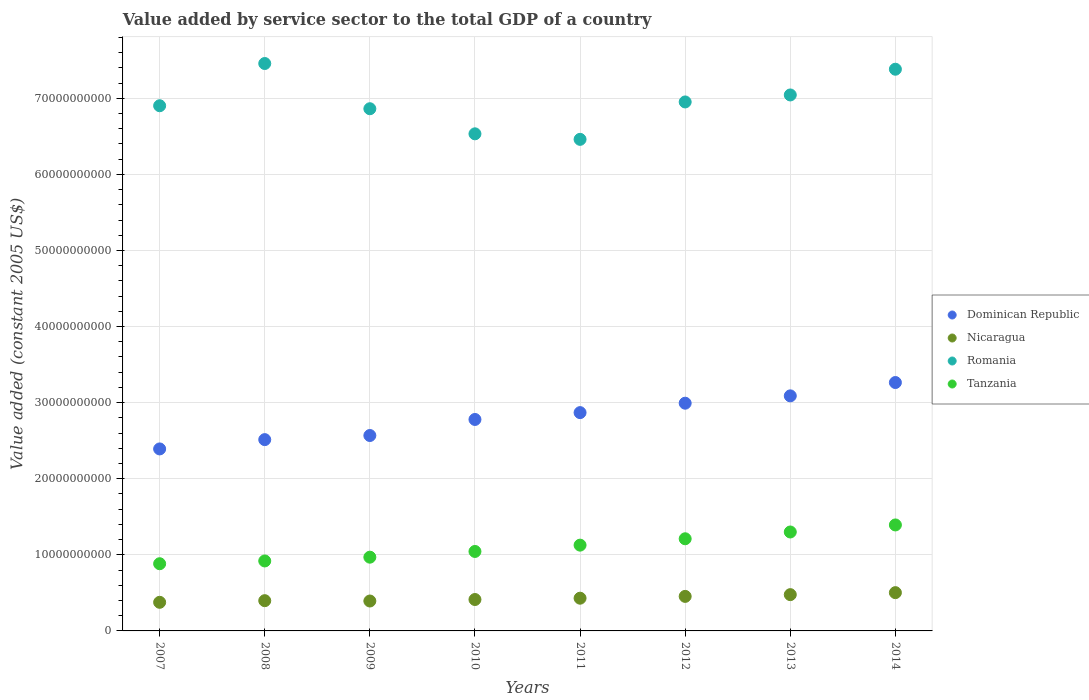What is the value added by service sector in Tanzania in 2011?
Ensure brevity in your answer.  1.13e+1. Across all years, what is the maximum value added by service sector in Nicaragua?
Offer a very short reply. 5.03e+09. Across all years, what is the minimum value added by service sector in Tanzania?
Provide a short and direct response. 8.83e+09. In which year was the value added by service sector in Dominican Republic maximum?
Ensure brevity in your answer.  2014. What is the total value added by service sector in Dominican Republic in the graph?
Ensure brevity in your answer.  2.25e+11. What is the difference between the value added by service sector in Dominican Republic in 2007 and that in 2010?
Provide a succinct answer. -3.87e+09. What is the difference between the value added by service sector in Dominican Republic in 2007 and the value added by service sector in Romania in 2012?
Keep it short and to the point. -4.56e+1. What is the average value added by service sector in Dominican Republic per year?
Provide a succinct answer. 2.81e+1. In the year 2012, what is the difference between the value added by service sector in Dominican Republic and value added by service sector in Nicaragua?
Ensure brevity in your answer.  2.54e+1. What is the ratio of the value added by service sector in Dominican Republic in 2007 to that in 2013?
Ensure brevity in your answer.  0.77. Is the value added by service sector in Romania in 2011 less than that in 2013?
Make the answer very short. Yes. What is the difference between the highest and the second highest value added by service sector in Tanzania?
Ensure brevity in your answer.  9.26e+08. What is the difference between the highest and the lowest value added by service sector in Romania?
Give a very brief answer. 9.97e+09. In how many years, is the value added by service sector in Nicaragua greater than the average value added by service sector in Nicaragua taken over all years?
Your answer should be very brief. 3. Is it the case that in every year, the sum of the value added by service sector in Tanzania and value added by service sector in Dominican Republic  is greater than the value added by service sector in Romania?
Give a very brief answer. No. Does the value added by service sector in Nicaragua monotonically increase over the years?
Make the answer very short. No. Is the value added by service sector in Nicaragua strictly less than the value added by service sector in Romania over the years?
Ensure brevity in your answer.  Yes. How many years are there in the graph?
Provide a succinct answer. 8. Are the values on the major ticks of Y-axis written in scientific E-notation?
Your answer should be compact. No. Does the graph contain any zero values?
Make the answer very short. No. Does the graph contain grids?
Keep it short and to the point. Yes. How many legend labels are there?
Make the answer very short. 4. How are the legend labels stacked?
Ensure brevity in your answer.  Vertical. What is the title of the graph?
Give a very brief answer. Value added by service sector to the total GDP of a country. Does "Costa Rica" appear as one of the legend labels in the graph?
Ensure brevity in your answer.  No. What is the label or title of the X-axis?
Offer a very short reply. Years. What is the label or title of the Y-axis?
Ensure brevity in your answer.  Value added (constant 2005 US$). What is the Value added (constant 2005 US$) of Dominican Republic in 2007?
Your response must be concise. 2.39e+1. What is the Value added (constant 2005 US$) in Nicaragua in 2007?
Your response must be concise. 3.76e+09. What is the Value added (constant 2005 US$) of Romania in 2007?
Provide a short and direct response. 6.90e+1. What is the Value added (constant 2005 US$) in Tanzania in 2007?
Your answer should be very brief. 8.83e+09. What is the Value added (constant 2005 US$) in Dominican Republic in 2008?
Keep it short and to the point. 2.51e+1. What is the Value added (constant 2005 US$) in Nicaragua in 2008?
Give a very brief answer. 3.97e+09. What is the Value added (constant 2005 US$) in Romania in 2008?
Your answer should be compact. 7.46e+1. What is the Value added (constant 2005 US$) of Tanzania in 2008?
Give a very brief answer. 9.20e+09. What is the Value added (constant 2005 US$) in Dominican Republic in 2009?
Offer a very short reply. 2.57e+1. What is the Value added (constant 2005 US$) of Nicaragua in 2009?
Give a very brief answer. 3.93e+09. What is the Value added (constant 2005 US$) of Romania in 2009?
Keep it short and to the point. 6.86e+1. What is the Value added (constant 2005 US$) in Tanzania in 2009?
Offer a very short reply. 9.69e+09. What is the Value added (constant 2005 US$) in Dominican Republic in 2010?
Give a very brief answer. 2.78e+1. What is the Value added (constant 2005 US$) in Nicaragua in 2010?
Your answer should be very brief. 4.13e+09. What is the Value added (constant 2005 US$) in Romania in 2010?
Your answer should be very brief. 6.53e+1. What is the Value added (constant 2005 US$) of Tanzania in 2010?
Ensure brevity in your answer.  1.04e+1. What is the Value added (constant 2005 US$) of Dominican Republic in 2011?
Make the answer very short. 2.87e+1. What is the Value added (constant 2005 US$) of Nicaragua in 2011?
Your answer should be very brief. 4.30e+09. What is the Value added (constant 2005 US$) in Romania in 2011?
Offer a very short reply. 6.46e+1. What is the Value added (constant 2005 US$) in Tanzania in 2011?
Offer a very short reply. 1.13e+1. What is the Value added (constant 2005 US$) of Dominican Republic in 2012?
Your answer should be compact. 2.99e+1. What is the Value added (constant 2005 US$) of Nicaragua in 2012?
Your answer should be compact. 4.54e+09. What is the Value added (constant 2005 US$) of Romania in 2012?
Provide a succinct answer. 6.95e+1. What is the Value added (constant 2005 US$) of Tanzania in 2012?
Make the answer very short. 1.21e+1. What is the Value added (constant 2005 US$) of Dominican Republic in 2013?
Make the answer very short. 3.09e+1. What is the Value added (constant 2005 US$) of Nicaragua in 2013?
Give a very brief answer. 4.77e+09. What is the Value added (constant 2005 US$) of Romania in 2013?
Your answer should be compact. 7.04e+1. What is the Value added (constant 2005 US$) in Tanzania in 2013?
Provide a succinct answer. 1.30e+1. What is the Value added (constant 2005 US$) in Dominican Republic in 2014?
Offer a terse response. 3.26e+1. What is the Value added (constant 2005 US$) in Nicaragua in 2014?
Keep it short and to the point. 5.03e+09. What is the Value added (constant 2005 US$) in Romania in 2014?
Provide a succinct answer. 7.38e+1. What is the Value added (constant 2005 US$) of Tanzania in 2014?
Keep it short and to the point. 1.39e+1. Across all years, what is the maximum Value added (constant 2005 US$) in Dominican Republic?
Provide a short and direct response. 3.26e+1. Across all years, what is the maximum Value added (constant 2005 US$) of Nicaragua?
Give a very brief answer. 5.03e+09. Across all years, what is the maximum Value added (constant 2005 US$) in Romania?
Offer a very short reply. 7.46e+1. Across all years, what is the maximum Value added (constant 2005 US$) of Tanzania?
Your answer should be compact. 1.39e+1. Across all years, what is the minimum Value added (constant 2005 US$) in Dominican Republic?
Give a very brief answer. 2.39e+1. Across all years, what is the minimum Value added (constant 2005 US$) in Nicaragua?
Give a very brief answer. 3.76e+09. Across all years, what is the minimum Value added (constant 2005 US$) of Romania?
Your response must be concise. 6.46e+1. Across all years, what is the minimum Value added (constant 2005 US$) in Tanzania?
Your response must be concise. 8.83e+09. What is the total Value added (constant 2005 US$) in Dominican Republic in the graph?
Keep it short and to the point. 2.25e+11. What is the total Value added (constant 2005 US$) of Nicaragua in the graph?
Keep it short and to the point. 3.44e+1. What is the total Value added (constant 2005 US$) of Romania in the graph?
Your answer should be very brief. 5.56e+11. What is the total Value added (constant 2005 US$) in Tanzania in the graph?
Your response must be concise. 8.85e+1. What is the difference between the Value added (constant 2005 US$) of Dominican Republic in 2007 and that in 2008?
Your answer should be very brief. -1.22e+09. What is the difference between the Value added (constant 2005 US$) in Nicaragua in 2007 and that in 2008?
Offer a very short reply. -2.14e+08. What is the difference between the Value added (constant 2005 US$) in Romania in 2007 and that in 2008?
Keep it short and to the point. -5.55e+09. What is the difference between the Value added (constant 2005 US$) in Tanzania in 2007 and that in 2008?
Your answer should be very brief. -3.64e+08. What is the difference between the Value added (constant 2005 US$) in Dominican Republic in 2007 and that in 2009?
Provide a succinct answer. -1.76e+09. What is the difference between the Value added (constant 2005 US$) of Nicaragua in 2007 and that in 2009?
Provide a short and direct response. -1.70e+08. What is the difference between the Value added (constant 2005 US$) in Romania in 2007 and that in 2009?
Provide a succinct answer. 3.93e+08. What is the difference between the Value added (constant 2005 US$) in Tanzania in 2007 and that in 2009?
Provide a short and direct response. -8.60e+08. What is the difference between the Value added (constant 2005 US$) in Dominican Republic in 2007 and that in 2010?
Provide a short and direct response. -3.87e+09. What is the difference between the Value added (constant 2005 US$) of Nicaragua in 2007 and that in 2010?
Your answer should be compact. -3.67e+08. What is the difference between the Value added (constant 2005 US$) in Romania in 2007 and that in 2010?
Provide a succinct answer. 3.69e+09. What is the difference between the Value added (constant 2005 US$) of Tanzania in 2007 and that in 2010?
Give a very brief answer. -1.61e+09. What is the difference between the Value added (constant 2005 US$) of Dominican Republic in 2007 and that in 2011?
Make the answer very short. -4.77e+09. What is the difference between the Value added (constant 2005 US$) of Nicaragua in 2007 and that in 2011?
Your answer should be compact. -5.40e+08. What is the difference between the Value added (constant 2005 US$) of Romania in 2007 and that in 2011?
Ensure brevity in your answer.  4.42e+09. What is the difference between the Value added (constant 2005 US$) in Tanzania in 2007 and that in 2011?
Keep it short and to the point. -2.44e+09. What is the difference between the Value added (constant 2005 US$) in Dominican Republic in 2007 and that in 2012?
Give a very brief answer. -6.01e+09. What is the difference between the Value added (constant 2005 US$) in Nicaragua in 2007 and that in 2012?
Your answer should be very brief. -7.78e+08. What is the difference between the Value added (constant 2005 US$) in Romania in 2007 and that in 2012?
Offer a very short reply. -4.99e+08. What is the difference between the Value added (constant 2005 US$) in Tanzania in 2007 and that in 2012?
Offer a very short reply. -3.28e+09. What is the difference between the Value added (constant 2005 US$) in Dominican Republic in 2007 and that in 2013?
Make the answer very short. -6.97e+09. What is the difference between the Value added (constant 2005 US$) of Nicaragua in 2007 and that in 2013?
Your answer should be compact. -1.01e+09. What is the difference between the Value added (constant 2005 US$) of Romania in 2007 and that in 2013?
Your answer should be very brief. -1.42e+09. What is the difference between the Value added (constant 2005 US$) in Tanzania in 2007 and that in 2013?
Your answer should be very brief. -4.17e+09. What is the difference between the Value added (constant 2005 US$) of Dominican Republic in 2007 and that in 2014?
Your response must be concise. -8.73e+09. What is the difference between the Value added (constant 2005 US$) of Nicaragua in 2007 and that in 2014?
Keep it short and to the point. -1.27e+09. What is the difference between the Value added (constant 2005 US$) in Romania in 2007 and that in 2014?
Your answer should be compact. -4.80e+09. What is the difference between the Value added (constant 2005 US$) of Tanzania in 2007 and that in 2014?
Keep it short and to the point. -5.10e+09. What is the difference between the Value added (constant 2005 US$) in Dominican Republic in 2008 and that in 2009?
Keep it short and to the point. -5.41e+08. What is the difference between the Value added (constant 2005 US$) in Nicaragua in 2008 and that in 2009?
Your answer should be very brief. 4.43e+07. What is the difference between the Value added (constant 2005 US$) of Romania in 2008 and that in 2009?
Provide a short and direct response. 5.94e+09. What is the difference between the Value added (constant 2005 US$) of Tanzania in 2008 and that in 2009?
Provide a succinct answer. -4.96e+08. What is the difference between the Value added (constant 2005 US$) of Dominican Republic in 2008 and that in 2010?
Make the answer very short. -2.65e+09. What is the difference between the Value added (constant 2005 US$) in Nicaragua in 2008 and that in 2010?
Offer a terse response. -1.53e+08. What is the difference between the Value added (constant 2005 US$) in Romania in 2008 and that in 2010?
Ensure brevity in your answer.  9.24e+09. What is the difference between the Value added (constant 2005 US$) of Tanzania in 2008 and that in 2010?
Keep it short and to the point. -1.25e+09. What is the difference between the Value added (constant 2005 US$) in Dominican Republic in 2008 and that in 2011?
Offer a terse response. -3.55e+09. What is the difference between the Value added (constant 2005 US$) in Nicaragua in 2008 and that in 2011?
Keep it short and to the point. -3.26e+08. What is the difference between the Value added (constant 2005 US$) of Romania in 2008 and that in 2011?
Keep it short and to the point. 9.97e+09. What is the difference between the Value added (constant 2005 US$) in Tanzania in 2008 and that in 2011?
Provide a short and direct response. -2.08e+09. What is the difference between the Value added (constant 2005 US$) of Dominican Republic in 2008 and that in 2012?
Your answer should be compact. -4.79e+09. What is the difference between the Value added (constant 2005 US$) of Nicaragua in 2008 and that in 2012?
Provide a short and direct response. -5.63e+08. What is the difference between the Value added (constant 2005 US$) of Romania in 2008 and that in 2012?
Your answer should be compact. 5.05e+09. What is the difference between the Value added (constant 2005 US$) in Tanzania in 2008 and that in 2012?
Give a very brief answer. -2.92e+09. What is the difference between the Value added (constant 2005 US$) of Dominican Republic in 2008 and that in 2013?
Ensure brevity in your answer.  -5.75e+09. What is the difference between the Value added (constant 2005 US$) in Nicaragua in 2008 and that in 2013?
Offer a very short reply. -7.93e+08. What is the difference between the Value added (constant 2005 US$) of Romania in 2008 and that in 2013?
Keep it short and to the point. 4.13e+09. What is the difference between the Value added (constant 2005 US$) of Tanzania in 2008 and that in 2013?
Provide a short and direct response. -3.81e+09. What is the difference between the Value added (constant 2005 US$) of Dominican Republic in 2008 and that in 2014?
Keep it short and to the point. -7.50e+09. What is the difference between the Value added (constant 2005 US$) in Nicaragua in 2008 and that in 2014?
Keep it short and to the point. -1.06e+09. What is the difference between the Value added (constant 2005 US$) of Romania in 2008 and that in 2014?
Make the answer very short. 7.50e+08. What is the difference between the Value added (constant 2005 US$) of Tanzania in 2008 and that in 2014?
Provide a short and direct response. -4.73e+09. What is the difference between the Value added (constant 2005 US$) of Dominican Republic in 2009 and that in 2010?
Keep it short and to the point. -2.11e+09. What is the difference between the Value added (constant 2005 US$) of Nicaragua in 2009 and that in 2010?
Your response must be concise. -1.97e+08. What is the difference between the Value added (constant 2005 US$) in Romania in 2009 and that in 2010?
Your answer should be very brief. 3.30e+09. What is the difference between the Value added (constant 2005 US$) in Tanzania in 2009 and that in 2010?
Make the answer very short. -7.53e+08. What is the difference between the Value added (constant 2005 US$) in Dominican Republic in 2009 and that in 2011?
Your answer should be very brief. -3.01e+09. What is the difference between the Value added (constant 2005 US$) of Nicaragua in 2009 and that in 2011?
Keep it short and to the point. -3.70e+08. What is the difference between the Value added (constant 2005 US$) of Romania in 2009 and that in 2011?
Your response must be concise. 4.02e+09. What is the difference between the Value added (constant 2005 US$) of Tanzania in 2009 and that in 2011?
Give a very brief answer. -1.58e+09. What is the difference between the Value added (constant 2005 US$) in Dominican Republic in 2009 and that in 2012?
Your response must be concise. -4.25e+09. What is the difference between the Value added (constant 2005 US$) in Nicaragua in 2009 and that in 2012?
Your response must be concise. -6.08e+08. What is the difference between the Value added (constant 2005 US$) of Romania in 2009 and that in 2012?
Provide a short and direct response. -8.91e+08. What is the difference between the Value added (constant 2005 US$) in Tanzania in 2009 and that in 2012?
Keep it short and to the point. -2.42e+09. What is the difference between the Value added (constant 2005 US$) in Dominican Republic in 2009 and that in 2013?
Provide a short and direct response. -5.21e+09. What is the difference between the Value added (constant 2005 US$) of Nicaragua in 2009 and that in 2013?
Offer a very short reply. -8.38e+08. What is the difference between the Value added (constant 2005 US$) of Romania in 2009 and that in 2013?
Offer a very short reply. -1.81e+09. What is the difference between the Value added (constant 2005 US$) of Tanzania in 2009 and that in 2013?
Make the answer very short. -3.31e+09. What is the difference between the Value added (constant 2005 US$) of Dominican Republic in 2009 and that in 2014?
Provide a short and direct response. -6.96e+09. What is the difference between the Value added (constant 2005 US$) in Nicaragua in 2009 and that in 2014?
Keep it short and to the point. -1.10e+09. What is the difference between the Value added (constant 2005 US$) in Romania in 2009 and that in 2014?
Keep it short and to the point. -5.19e+09. What is the difference between the Value added (constant 2005 US$) of Tanzania in 2009 and that in 2014?
Your response must be concise. -4.24e+09. What is the difference between the Value added (constant 2005 US$) of Dominican Republic in 2010 and that in 2011?
Your answer should be compact. -9.00e+08. What is the difference between the Value added (constant 2005 US$) of Nicaragua in 2010 and that in 2011?
Make the answer very short. -1.73e+08. What is the difference between the Value added (constant 2005 US$) of Romania in 2010 and that in 2011?
Give a very brief answer. 7.26e+08. What is the difference between the Value added (constant 2005 US$) of Tanzania in 2010 and that in 2011?
Keep it short and to the point. -8.30e+08. What is the difference between the Value added (constant 2005 US$) of Dominican Republic in 2010 and that in 2012?
Provide a short and direct response. -2.14e+09. What is the difference between the Value added (constant 2005 US$) in Nicaragua in 2010 and that in 2012?
Keep it short and to the point. -4.10e+08. What is the difference between the Value added (constant 2005 US$) in Romania in 2010 and that in 2012?
Provide a short and direct response. -4.19e+09. What is the difference between the Value added (constant 2005 US$) of Tanzania in 2010 and that in 2012?
Provide a short and direct response. -1.67e+09. What is the difference between the Value added (constant 2005 US$) in Dominican Republic in 2010 and that in 2013?
Your answer should be compact. -3.10e+09. What is the difference between the Value added (constant 2005 US$) of Nicaragua in 2010 and that in 2013?
Offer a very short reply. -6.40e+08. What is the difference between the Value added (constant 2005 US$) of Romania in 2010 and that in 2013?
Provide a short and direct response. -5.11e+09. What is the difference between the Value added (constant 2005 US$) of Tanzania in 2010 and that in 2013?
Provide a succinct answer. -2.56e+09. What is the difference between the Value added (constant 2005 US$) of Dominican Republic in 2010 and that in 2014?
Offer a very short reply. -4.85e+09. What is the difference between the Value added (constant 2005 US$) of Nicaragua in 2010 and that in 2014?
Provide a succinct answer. -9.02e+08. What is the difference between the Value added (constant 2005 US$) in Romania in 2010 and that in 2014?
Ensure brevity in your answer.  -8.49e+09. What is the difference between the Value added (constant 2005 US$) in Tanzania in 2010 and that in 2014?
Your answer should be very brief. -3.48e+09. What is the difference between the Value added (constant 2005 US$) of Dominican Republic in 2011 and that in 2012?
Your answer should be very brief. -1.24e+09. What is the difference between the Value added (constant 2005 US$) of Nicaragua in 2011 and that in 2012?
Offer a very short reply. -2.38e+08. What is the difference between the Value added (constant 2005 US$) in Romania in 2011 and that in 2012?
Offer a very short reply. -4.92e+09. What is the difference between the Value added (constant 2005 US$) of Tanzania in 2011 and that in 2012?
Your answer should be very brief. -8.38e+08. What is the difference between the Value added (constant 2005 US$) of Dominican Republic in 2011 and that in 2013?
Offer a terse response. -2.20e+09. What is the difference between the Value added (constant 2005 US$) in Nicaragua in 2011 and that in 2013?
Keep it short and to the point. -4.68e+08. What is the difference between the Value added (constant 2005 US$) in Romania in 2011 and that in 2013?
Offer a terse response. -5.83e+09. What is the difference between the Value added (constant 2005 US$) in Tanzania in 2011 and that in 2013?
Your answer should be compact. -1.73e+09. What is the difference between the Value added (constant 2005 US$) in Dominican Republic in 2011 and that in 2014?
Your answer should be very brief. -3.95e+09. What is the difference between the Value added (constant 2005 US$) in Nicaragua in 2011 and that in 2014?
Your answer should be very brief. -7.29e+08. What is the difference between the Value added (constant 2005 US$) of Romania in 2011 and that in 2014?
Make the answer very short. -9.22e+09. What is the difference between the Value added (constant 2005 US$) of Tanzania in 2011 and that in 2014?
Offer a very short reply. -2.65e+09. What is the difference between the Value added (constant 2005 US$) in Dominican Republic in 2012 and that in 2013?
Your answer should be very brief. -9.64e+08. What is the difference between the Value added (constant 2005 US$) in Nicaragua in 2012 and that in 2013?
Keep it short and to the point. -2.30e+08. What is the difference between the Value added (constant 2005 US$) of Romania in 2012 and that in 2013?
Give a very brief answer. -9.19e+08. What is the difference between the Value added (constant 2005 US$) in Tanzania in 2012 and that in 2013?
Your answer should be very brief. -8.90e+08. What is the difference between the Value added (constant 2005 US$) in Dominican Republic in 2012 and that in 2014?
Offer a terse response. -2.72e+09. What is the difference between the Value added (constant 2005 US$) of Nicaragua in 2012 and that in 2014?
Offer a very short reply. -4.92e+08. What is the difference between the Value added (constant 2005 US$) of Romania in 2012 and that in 2014?
Your answer should be very brief. -4.30e+09. What is the difference between the Value added (constant 2005 US$) in Tanzania in 2012 and that in 2014?
Give a very brief answer. -1.82e+09. What is the difference between the Value added (constant 2005 US$) in Dominican Republic in 2013 and that in 2014?
Your answer should be compact. -1.75e+09. What is the difference between the Value added (constant 2005 US$) in Nicaragua in 2013 and that in 2014?
Offer a very short reply. -2.62e+08. What is the difference between the Value added (constant 2005 US$) in Romania in 2013 and that in 2014?
Provide a succinct answer. -3.38e+09. What is the difference between the Value added (constant 2005 US$) of Tanzania in 2013 and that in 2014?
Offer a terse response. -9.26e+08. What is the difference between the Value added (constant 2005 US$) in Dominican Republic in 2007 and the Value added (constant 2005 US$) in Nicaragua in 2008?
Your answer should be very brief. 1.99e+1. What is the difference between the Value added (constant 2005 US$) of Dominican Republic in 2007 and the Value added (constant 2005 US$) of Romania in 2008?
Your answer should be very brief. -5.07e+1. What is the difference between the Value added (constant 2005 US$) in Dominican Republic in 2007 and the Value added (constant 2005 US$) in Tanzania in 2008?
Offer a terse response. 1.47e+1. What is the difference between the Value added (constant 2005 US$) of Nicaragua in 2007 and the Value added (constant 2005 US$) of Romania in 2008?
Give a very brief answer. -7.08e+1. What is the difference between the Value added (constant 2005 US$) of Nicaragua in 2007 and the Value added (constant 2005 US$) of Tanzania in 2008?
Make the answer very short. -5.44e+09. What is the difference between the Value added (constant 2005 US$) of Romania in 2007 and the Value added (constant 2005 US$) of Tanzania in 2008?
Provide a succinct answer. 5.98e+1. What is the difference between the Value added (constant 2005 US$) of Dominican Republic in 2007 and the Value added (constant 2005 US$) of Nicaragua in 2009?
Keep it short and to the point. 2.00e+1. What is the difference between the Value added (constant 2005 US$) in Dominican Republic in 2007 and the Value added (constant 2005 US$) in Romania in 2009?
Offer a very short reply. -4.47e+1. What is the difference between the Value added (constant 2005 US$) of Dominican Republic in 2007 and the Value added (constant 2005 US$) of Tanzania in 2009?
Offer a terse response. 1.42e+1. What is the difference between the Value added (constant 2005 US$) of Nicaragua in 2007 and the Value added (constant 2005 US$) of Romania in 2009?
Your answer should be compact. -6.49e+1. What is the difference between the Value added (constant 2005 US$) of Nicaragua in 2007 and the Value added (constant 2005 US$) of Tanzania in 2009?
Provide a short and direct response. -5.93e+09. What is the difference between the Value added (constant 2005 US$) in Romania in 2007 and the Value added (constant 2005 US$) in Tanzania in 2009?
Ensure brevity in your answer.  5.93e+1. What is the difference between the Value added (constant 2005 US$) in Dominican Republic in 2007 and the Value added (constant 2005 US$) in Nicaragua in 2010?
Offer a very short reply. 1.98e+1. What is the difference between the Value added (constant 2005 US$) in Dominican Republic in 2007 and the Value added (constant 2005 US$) in Romania in 2010?
Make the answer very short. -4.14e+1. What is the difference between the Value added (constant 2005 US$) in Dominican Republic in 2007 and the Value added (constant 2005 US$) in Tanzania in 2010?
Your answer should be very brief. 1.35e+1. What is the difference between the Value added (constant 2005 US$) of Nicaragua in 2007 and the Value added (constant 2005 US$) of Romania in 2010?
Provide a short and direct response. -6.16e+1. What is the difference between the Value added (constant 2005 US$) of Nicaragua in 2007 and the Value added (constant 2005 US$) of Tanzania in 2010?
Your answer should be compact. -6.68e+09. What is the difference between the Value added (constant 2005 US$) in Romania in 2007 and the Value added (constant 2005 US$) in Tanzania in 2010?
Your response must be concise. 5.86e+1. What is the difference between the Value added (constant 2005 US$) in Dominican Republic in 2007 and the Value added (constant 2005 US$) in Nicaragua in 2011?
Offer a very short reply. 1.96e+1. What is the difference between the Value added (constant 2005 US$) in Dominican Republic in 2007 and the Value added (constant 2005 US$) in Romania in 2011?
Give a very brief answer. -4.07e+1. What is the difference between the Value added (constant 2005 US$) in Dominican Republic in 2007 and the Value added (constant 2005 US$) in Tanzania in 2011?
Offer a very short reply. 1.26e+1. What is the difference between the Value added (constant 2005 US$) in Nicaragua in 2007 and the Value added (constant 2005 US$) in Romania in 2011?
Your answer should be compact. -6.08e+1. What is the difference between the Value added (constant 2005 US$) in Nicaragua in 2007 and the Value added (constant 2005 US$) in Tanzania in 2011?
Offer a terse response. -7.51e+09. What is the difference between the Value added (constant 2005 US$) in Romania in 2007 and the Value added (constant 2005 US$) in Tanzania in 2011?
Ensure brevity in your answer.  5.77e+1. What is the difference between the Value added (constant 2005 US$) of Dominican Republic in 2007 and the Value added (constant 2005 US$) of Nicaragua in 2012?
Offer a very short reply. 1.94e+1. What is the difference between the Value added (constant 2005 US$) in Dominican Republic in 2007 and the Value added (constant 2005 US$) in Romania in 2012?
Your response must be concise. -4.56e+1. What is the difference between the Value added (constant 2005 US$) of Dominican Republic in 2007 and the Value added (constant 2005 US$) of Tanzania in 2012?
Keep it short and to the point. 1.18e+1. What is the difference between the Value added (constant 2005 US$) of Nicaragua in 2007 and the Value added (constant 2005 US$) of Romania in 2012?
Keep it short and to the point. -6.58e+1. What is the difference between the Value added (constant 2005 US$) of Nicaragua in 2007 and the Value added (constant 2005 US$) of Tanzania in 2012?
Your response must be concise. -8.35e+09. What is the difference between the Value added (constant 2005 US$) in Romania in 2007 and the Value added (constant 2005 US$) in Tanzania in 2012?
Keep it short and to the point. 5.69e+1. What is the difference between the Value added (constant 2005 US$) of Dominican Republic in 2007 and the Value added (constant 2005 US$) of Nicaragua in 2013?
Offer a very short reply. 1.92e+1. What is the difference between the Value added (constant 2005 US$) in Dominican Republic in 2007 and the Value added (constant 2005 US$) in Romania in 2013?
Your answer should be very brief. -4.65e+1. What is the difference between the Value added (constant 2005 US$) in Dominican Republic in 2007 and the Value added (constant 2005 US$) in Tanzania in 2013?
Ensure brevity in your answer.  1.09e+1. What is the difference between the Value added (constant 2005 US$) of Nicaragua in 2007 and the Value added (constant 2005 US$) of Romania in 2013?
Your answer should be very brief. -6.67e+1. What is the difference between the Value added (constant 2005 US$) in Nicaragua in 2007 and the Value added (constant 2005 US$) in Tanzania in 2013?
Offer a terse response. -9.24e+09. What is the difference between the Value added (constant 2005 US$) in Romania in 2007 and the Value added (constant 2005 US$) in Tanzania in 2013?
Keep it short and to the point. 5.60e+1. What is the difference between the Value added (constant 2005 US$) in Dominican Republic in 2007 and the Value added (constant 2005 US$) in Nicaragua in 2014?
Your answer should be very brief. 1.89e+1. What is the difference between the Value added (constant 2005 US$) in Dominican Republic in 2007 and the Value added (constant 2005 US$) in Romania in 2014?
Provide a short and direct response. -4.99e+1. What is the difference between the Value added (constant 2005 US$) in Dominican Republic in 2007 and the Value added (constant 2005 US$) in Tanzania in 2014?
Your answer should be very brief. 9.99e+09. What is the difference between the Value added (constant 2005 US$) of Nicaragua in 2007 and the Value added (constant 2005 US$) of Romania in 2014?
Provide a succinct answer. -7.01e+1. What is the difference between the Value added (constant 2005 US$) in Nicaragua in 2007 and the Value added (constant 2005 US$) in Tanzania in 2014?
Give a very brief answer. -1.02e+1. What is the difference between the Value added (constant 2005 US$) in Romania in 2007 and the Value added (constant 2005 US$) in Tanzania in 2014?
Ensure brevity in your answer.  5.51e+1. What is the difference between the Value added (constant 2005 US$) in Dominican Republic in 2008 and the Value added (constant 2005 US$) in Nicaragua in 2009?
Offer a very short reply. 2.12e+1. What is the difference between the Value added (constant 2005 US$) of Dominican Republic in 2008 and the Value added (constant 2005 US$) of Romania in 2009?
Give a very brief answer. -4.35e+1. What is the difference between the Value added (constant 2005 US$) of Dominican Republic in 2008 and the Value added (constant 2005 US$) of Tanzania in 2009?
Provide a succinct answer. 1.54e+1. What is the difference between the Value added (constant 2005 US$) of Nicaragua in 2008 and the Value added (constant 2005 US$) of Romania in 2009?
Your answer should be compact. -6.47e+1. What is the difference between the Value added (constant 2005 US$) of Nicaragua in 2008 and the Value added (constant 2005 US$) of Tanzania in 2009?
Provide a succinct answer. -5.72e+09. What is the difference between the Value added (constant 2005 US$) of Romania in 2008 and the Value added (constant 2005 US$) of Tanzania in 2009?
Offer a terse response. 6.49e+1. What is the difference between the Value added (constant 2005 US$) in Dominican Republic in 2008 and the Value added (constant 2005 US$) in Nicaragua in 2010?
Your answer should be compact. 2.10e+1. What is the difference between the Value added (constant 2005 US$) of Dominican Republic in 2008 and the Value added (constant 2005 US$) of Romania in 2010?
Make the answer very short. -4.02e+1. What is the difference between the Value added (constant 2005 US$) in Dominican Republic in 2008 and the Value added (constant 2005 US$) in Tanzania in 2010?
Provide a short and direct response. 1.47e+1. What is the difference between the Value added (constant 2005 US$) in Nicaragua in 2008 and the Value added (constant 2005 US$) in Romania in 2010?
Your response must be concise. -6.14e+1. What is the difference between the Value added (constant 2005 US$) in Nicaragua in 2008 and the Value added (constant 2005 US$) in Tanzania in 2010?
Provide a succinct answer. -6.47e+09. What is the difference between the Value added (constant 2005 US$) in Romania in 2008 and the Value added (constant 2005 US$) in Tanzania in 2010?
Make the answer very short. 6.41e+1. What is the difference between the Value added (constant 2005 US$) in Dominican Republic in 2008 and the Value added (constant 2005 US$) in Nicaragua in 2011?
Give a very brief answer. 2.08e+1. What is the difference between the Value added (constant 2005 US$) in Dominican Republic in 2008 and the Value added (constant 2005 US$) in Romania in 2011?
Your answer should be compact. -3.95e+1. What is the difference between the Value added (constant 2005 US$) of Dominican Republic in 2008 and the Value added (constant 2005 US$) of Tanzania in 2011?
Your answer should be compact. 1.39e+1. What is the difference between the Value added (constant 2005 US$) of Nicaragua in 2008 and the Value added (constant 2005 US$) of Romania in 2011?
Offer a very short reply. -6.06e+1. What is the difference between the Value added (constant 2005 US$) of Nicaragua in 2008 and the Value added (constant 2005 US$) of Tanzania in 2011?
Provide a short and direct response. -7.30e+09. What is the difference between the Value added (constant 2005 US$) in Romania in 2008 and the Value added (constant 2005 US$) in Tanzania in 2011?
Your response must be concise. 6.33e+1. What is the difference between the Value added (constant 2005 US$) in Dominican Republic in 2008 and the Value added (constant 2005 US$) in Nicaragua in 2012?
Offer a terse response. 2.06e+1. What is the difference between the Value added (constant 2005 US$) of Dominican Republic in 2008 and the Value added (constant 2005 US$) of Romania in 2012?
Ensure brevity in your answer.  -4.44e+1. What is the difference between the Value added (constant 2005 US$) in Dominican Republic in 2008 and the Value added (constant 2005 US$) in Tanzania in 2012?
Keep it short and to the point. 1.30e+1. What is the difference between the Value added (constant 2005 US$) of Nicaragua in 2008 and the Value added (constant 2005 US$) of Romania in 2012?
Your response must be concise. -6.55e+1. What is the difference between the Value added (constant 2005 US$) in Nicaragua in 2008 and the Value added (constant 2005 US$) in Tanzania in 2012?
Keep it short and to the point. -8.14e+09. What is the difference between the Value added (constant 2005 US$) in Romania in 2008 and the Value added (constant 2005 US$) in Tanzania in 2012?
Your answer should be compact. 6.25e+1. What is the difference between the Value added (constant 2005 US$) of Dominican Republic in 2008 and the Value added (constant 2005 US$) of Nicaragua in 2013?
Ensure brevity in your answer.  2.04e+1. What is the difference between the Value added (constant 2005 US$) in Dominican Republic in 2008 and the Value added (constant 2005 US$) in Romania in 2013?
Provide a succinct answer. -4.53e+1. What is the difference between the Value added (constant 2005 US$) in Dominican Republic in 2008 and the Value added (constant 2005 US$) in Tanzania in 2013?
Your answer should be very brief. 1.21e+1. What is the difference between the Value added (constant 2005 US$) in Nicaragua in 2008 and the Value added (constant 2005 US$) in Romania in 2013?
Give a very brief answer. -6.65e+1. What is the difference between the Value added (constant 2005 US$) in Nicaragua in 2008 and the Value added (constant 2005 US$) in Tanzania in 2013?
Provide a succinct answer. -9.03e+09. What is the difference between the Value added (constant 2005 US$) of Romania in 2008 and the Value added (constant 2005 US$) of Tanzania in 2013?
Offer a terse response. 6.16e+1. What is the difference between the Value added (constant 2005 US$) of Dominican Republic in 2008 and the Value added (constant 2005 US$) of Nicaragua in 2014?
Ensure brevity in your answer.  2.01e+1. What is the difference between the Value added (constant 2005 US$) in Dominican Republic in 2008 and the Value added (constant 2005 US$) in Romania in 2014?
Your answer should be compact. -4.87e+1. What is the difference between the Value added (constant 2005 US$) in Dominican Republic in 2008 and the Value added (constant 2005 US$) in Tanzania in 2014?
Provide a short and direct response. 1.12e+1. What is the difference between the Value added (constant 2005 US$) in Nicaragua in 2008 and the Value added (constant 2005 US$) in Romania in 2014?
Make the answer very short. -6.98e+1. What is the difference between the Value added (constant 2005 US$) in Nicaragua in 2008 and the Value added (constant 2005 US$) in Tanzania in 2014?
Offer a very short reply. -9.95e+09. What is the difference between the Value added (constant 2005 US$) of Romania in 2008 and the Value added (constant 2005 US$) of Tanzania in 2014?
Offer a very short reply. 6.06e+1. What is the difference between the Value added (constant 2005 US$) in Dominican Republic in 2009 and the Value added (constant 2005 US$) in Nicaragua in 2010?
Keep it short and to the point. 2.16e+1. What is the difference between the Value added (constant 2005 US$) of Dominican Republic in 2009 and the Value added (constant 2005 US$) of Romania in 2010?
Your answer should be compact. -3.96e+1. What is the difference between the Value added (constant 2005 US$) of Dominican Republic in 2009 and the Value added (constant 2005 US$) of Tanzania in 2010?
Make the answer very short. 1.52e+1. What is the difference between the Value added (constant 2005 US$) in Nicaragua in 2009 and the Value added (constant 2005 US$) in Romania in 2010?
Your response must be concise. -6.14e+1. What is the difference between the Value added (constant 2005 US$) in Nicaragua in 2009 and the Value added (constant 2005 US$) in Tanzania in 2010?
Your response must be concise. -6.51e+09. What is the difference between the Value added (constant 2005 US$) of Romania in 2009 and the Value added (constant 2005 US$) of Tanzania in 2010?
Your response must be concise. 5.82e+1. What is the difference between the Value added (constant 2005 US$) of Dominican Republic in 2009 and the Value added (constant 2005 US$) of Nicaragua in 2011?
Keep it short and to the point. 2.14e+1. What is the difference between the Value added (constant 2005 US$) of Dominican Republic in 2009 and the Value added (constant 2005 US$) of Romania in 2011?
Make the answer very short. -3.89e+1. What is the difference between the Value added (constant 2005 US$) in Dominican Republic in 2009 and the Value added (constant 2005 US$) in Tanzania in 2011?
Give a very brief answer. 1.44e+1. What is the difference between the Value added (constant 2005 US$) in Nicaragua in 2009 and the Value added (constant 2005 US$) in Romania in 2011?
Make the answer very short. -6.07e+1. What is the difference between the Value added (constant 2005 US$) in Nicaragua in 2009 and the Value added (constant 2005 US$) in Tanzania in 2011?
Give a very brief answer. -7.34e+09. What is the difference between the Value added (constant 2005 US$) in Romania in 2009 and the Value added (constant 2005 US$) in Tanzania in 2011?
Give a very brief answer. 5.74e+1. What is the difference between the Value added (constant 2005 US$) of Dominican Republic in 2009 and the Value added (constant 2005 US$) of Nicaragua in 2012?
Ensure brevity in your answer.  2.11e+1. What is the difference between the Value added (constant 2005 US$) of Dominican Republic in 2009 and the Value added (constant 2005 US$) of Romania in 2012?
Ensure brevity in your answer.  -4.38e+1. What is the difference between the Value added (constant 2005 US$) of Dominican Republic in 2009 and the Value added (constant 2005 US$) of Tanzania in 2012?
Provide a short and direct response. 1.36e+1. What is the difference between the Value added (constant 2005 US$) of Nicaragua in 2009 and the Value added (constant 2005 US$) of Romania in 2012?
Ensure brevity in your answer.  -6.56e+1. What is the difference between the Value added (constant 2005 US$) in Nicaragua in 2009 and the Value added (constant 2005 US$) in Tanzania in 2012?
Your response must be concise. -8.18e+09. What is the difference between the Value added (constant 2005 US$) of Romania in 2009 and the Value added (constant 2005 US$) of Tanzania in 2012?
Your answer should be very brief. 5.65e+1. What is the difference between the Value added (constant 2005 US$) in Dominican Republic in 2009 and the Value added (constant 2005 US$) in Nicaragua in 2013?
Make the answer very short. 2.09e+1. What is the difference between the Value added (constant 2005 US$) of Dominican Republic in 2009 and the Value added (constant 2005 US$) of Romania in 2013?
Your answer should be compact. -4.48e+1. What is the difference between the Value added (constant 2005 US$) of Dominican Republic in 2009 and the Value added (constant 2005 US$) of Tanzania in 2013?
Give a very brief answer. 1.27e+1. What is the difference between the Value added (constant 2005 US$) in Nicaragua in 2009 and the Value added (constant 2005 US$) in Romania in 2013?
Give a very brief answer. -6.65e+1. What is the difference between the Value added (constant 2005 US$) in Nicaragua in 2009 and the Value added (constant 2005 US$) in Tanzania in 2013?
Your answer should be compact. -9.07e+09. What is the difference between the Value added (constant 2005 US$) of Romania in 2009 and the Value added (constant 2005 US$) of Tanzania in 2013?
Ensure brevity in your answer.  5.56e+1. What is the difference between the Value added (constant 2005 US$) of Dominican Republic in 2009 and the Value added (constant 2005 US$) of Nicaragua in 2014?
Give a very brief answer. 2.07e+1. What is the difference between the Value added (constant 2005 US$) of Dominican Republic in 2009 and the Value added (constant 2005 US$) of Romania in 2014?
Provide a short and direct response. -4.81e+1. What is the difference between the Value added (constant 2005 US$) of Dominican Republic in 2009 and the Value added (constant 2005 US$) of Tanzania in 2014?
Your answer should be compact. 1.18e+1. What is the difference between the Value added (constant 2005 US$) in Nicaragua in 2009 and the Value added (constant 2005 US$) in Romania in 2014?
Give a very brief answer. -6.99e+1. What is the difference between the Value added (constant 2005 US$) in Nicaragua in 2009 and the Value added (constant 2005 US$) in Tanzania in 2014?
Ensure brevity in your answer.  -1.00e+1. What is the difference between the Value added (constant 2005 US$) of Romania in 2009 and the Value added (constant 2005 US$) of Tanzania in 2014?
Your answer should be very brief. 5.47e+1. What is the difference between the Value added (constant 2005 US$) of Dominican Republic in 2010 and the Value added (constant 2005 US$) of Nicaragua in 2011?
Make the answer very short. 2.35e+1. What is the difference between the Value added (constant 2005 US$) in Dominican Republic in 2010 and the Value added (constant 2005 US$) in Romania in 2011?
Offer a very short reply. -3.68e+1. What is the difference between the Value added (constant 2005 US$) of Dominican Republic in 2010 and the Value added (constant 2005 US$) of Tanzania in 2011?
Offer a very short reply. 1.65e+1. What is the difference between the Value added (constant 2005 US$) in Nicaragua in 2010 and the Value added (constant 2005 US$) in Romania in 2011?
Provide a short and direct response. -6.05e+1. What is the difference between the Value added (constant 2005 US$) in Nicaragua in 2010 and the Value added (constant 2005 US$) in Tanzania in 2011?
Keep it short and to the point. -7.15e+09. What is the difference between the Value added (constant 2005 US$) of Romania in 2010 and the Value added (constant 2005 US$) of Tanzania in 2011?
Offer a terse response. 5.41e+1. What is the difference between the Value added (constant 2005 US$) of Dominican Republic in 2010 and the Value added (constant 2005 US$) of Nicaragua in 2012?
Offer a very short reply. 2.33e+1. What is the difference between the Value added (constant 2005 US$) of Dominican Republic in 2010 and the Value added (constant 2005 US$) of Romania in 2012?
Offer a terse response. -4.17e+1. What is the difference between the Value added (constant 2005 US$) in Dominican Republic in 2010 and the Value added (constant 2005 US$) in Tanzania in 2012?
Keep it short and to the point. 1.57e+1. What is the difference between the Value added (constant 2005 US$) in Nicaragua in 2010 and the Value added (constant 2005 US$) in Romania in 2012?
Provide a short and direct response. -6.54e+1. What is the difference between the Value added (constant 2005 US$) in Nicaragua in 2010 and the Value added (constant 2005 US$) in Tanzania in 2012?
Your answer should be compact. -7.98e+09. What is the difference between the Value added (constant 2005 US$) of Romania in 2010 and the Value added (constant 2005 US$) of Tanzania in 2012?
Your response must be concise. 5.32e+1. What is the difference between the Value added (constant 2005 US$) in Dominican Republic in 2010 and the Value added (constant 2005 US$) in Nicaragua in 2013?
Provide a short and direct response. 2.30e+1. What is the difference between the Value added (constant 2005 US$) of Dominican Republic in 2010 and the Value added (constant 2005 US$) of Romania in 2013?
Keep it short and to the point. -4.26e+1. What is the difference between the Value added (constant 2005 US$) in Dominican Republic in 2010 and the Value added (constant 2005 US$) in Tanzania in 2013?
Your answer should be very brief. 1.48e+1. What is the difference between the Value added (constant 2005 US$) in Nicaragua in 2010 and the Value added (constant 2005 US$) in Romania in 2013?
Provide a short and direct response. -6.63e+1. What is the difference between the Value added (constant 2005 US$) of Nicaragua in 2010 and the Value added (constant 2005 US$) of Tanzania in 2013?
Give a very brief answer. -8.87e+09. What is the difference between the Value added (constant 2005 US$) of Romania in 2010 and the Value added (constant 2005 US$) of Tanzania in 2013?
Make the answer very short. 5.23e+1. What is the difference between the Value added (constant 2005 US$) in Dominican Republic in 2010 and the Value added (constant 2005 US$) in Nicaragua in 2014?
Your response must be concise. 2.28e+1. What is the difference between the Value added (constant 2005 US$) in Dominican Republic in 2010 and the Value added (constant 2005 US$) in Romania in 2014?
Offer a terse response. -4.60e+1. What is the difference between the Value added (constant 2005 US$) in Dominican Republic in 2010 and the Value added (constant 2005 US$) in Tanzania in 2014?
Your answer should be very brief. 1.39e+1. What is the difference between the Value added (constant 2005 US$) of Nicaragua in 2010 and the Value added (constant 2005 US$) of Romania in 2014?
Your answer should be compact. -6.97e+1. What is the difference between the Value added (constant 2005 US$) of Nicaragua in 2010 and the Value added (constant 2005 US$) of Tanzania in 2014?
Offer a terse response. -9.80e+09. What is the difference between the Value added (constant 2005 US$) of Romania in 2010 and the Value added (constant 2005 US$) of Tanzania in 2014?
Provide a short and direct response. 5.14e+1. What is the difference between the Value added (constant 2005 US$) in Dominican Republic in 2011 and the Value added (constant 2005 US$) in Nicaragua in 2012?
Ensure brevity in your answer.  2.42e+1. What is the difference between the Value added (constant 2005 US$) in Dominican Republic in 2011 and the Value added (constant 2005 US$) in Romania in 2012?
Provide a succinct answer. -4.08e+1. What is the difference between the Value added (constant 2005 US$) in Dominican Republic in 2011 and the Value added (constant 2005 US$) in Tanzania in 2012?
Provide a short and direct response. 1.66e+1. What is the difference between the Value added (constant 2005 US$) of Nicaragua in 2011 and the Value added (constant 2005 US$) of Romania in 2012?
Give a very brief answer. -6.52e+1. What is the difference between the Value added (constant 2005 US$) in Nicaragua in 2011 and the Value added (constant 2005 US$) in Tanzania in 2012?
Make the answer very short. -7.81e+09. What is the difference between the Value added (constant 2005 US$) of Romania in 2011 and the Value added (constant 2005 US$) of Tanzania in 2012?
Provide a succinct answer. 5.25e+1. What is the difference between the Value added (constant 2005 US$) in Dominican Republic in 2011 and the Value added (constant 2005 US$) in Nicaragua in 2013?
Offer a very short reply. 2.39e+1. What is the difference between the Value added (constant 2005 US$) of Dominican Republic in 2011 and the Value added (constant 2005 US$) of Romania in 2013?
Offer a very short reply. -4.17e+1. What is the difference between the Value added (constant 2005 US$) in Dominican Republic in 2011 and the Value added (constant 2005 US$) in Tanzania in 2013?
Provide a succinct answer. 1.57e+1. What is the difference between the Value added (constant 2005 US$) in Nicaragua in 2011 and the Value added (constant 2005 US$) in Romania in 2013?
Your answer should be compact. -6.61e+1. What is the difference between the Value added (constant 2005 US$) of Nicaragua in 2011 and the Value added (constant 2005 US$) of Tanzania in 2013?
Your answer should be compact. -8.70e+09. What is the difference between the Value added (constant 2005 US$) in Romania in 2011 and the Value added (constant 2005 US$) in Tanzania in 2013?
Your response must be concise. 5.16e+1. What is the difference between the Value added (constant 2005 US$) of Dominican Republic in 2011 and the Value added (constant 2005 US$) of Nicaragua in 2014?
Keep it short and to the point. 2.37e+1. What is the difference between the Value added (constant 2005 US$) of Dominican Republic in 2011 and the Value added (constant 2005 US$) of Romania in 2014?
Your response must be concise. -4.51e+1. What is the difference between the Value added (constant 2005 US$) in Dominican Republic in 2011 and the Value added (constant 2005 US$) in Tanzania in 2014?
Your response must be concise. 1.48e+1. What is the difference between the Value added (constant 2005 US$) in Nicaragua in 2011 and the Value added (constant 2005 US$) in Romania in 2014?
Give a very brief answer. -6.95e+1. What is the difference between the Value added (constant 2005 US$) of Nicaragua in 2011 and the Value added (constant 2005 US$) of Tanzania in 2014?
Give a very brief answer. -9.63e+09. What is the difference between the Value added (constant 2005 US$) of Romania in 2011 and the Value added (constant 2005 US$) of Tanzania in 2014?
Give a very brief answer. 5.07e+1. What is the difference between the Value added (constant 2005 US$) of Dominican Republic in 2012 and the Value added (constant 2005 US$) of Nicaragua in 2013?
Your answer should be very brief. 2.52e+1. What is the difference between the Value added (constant 2005 US$) in Dominican Republic in 2012 and the Value added (constant 2005 US$) in Romania in 2013?
Offer a terse response. -4.05e+1. What is the difference between the Value added (constant 2005 US$) in Dominican Republic in 2012 and the Value added (constant 2005 US$) in Tanzania in 2013?
Give a very brief answer. 1.69e+1. What is the difference between the Value added (constant 2005 US$) in Nicaragua in 2012 and the Value added (constant 2005 US$) in Romania in 2013?
Ensure brevity in your answer.  -6.59e+1. What is the difference between the Value added (constant 2005 US$) of Nicaragua in 2012 and the Value added (constant 2005 US$) of Tanzania in 2013?
Make the answer very short. -8.46e+09. What is the difference between the Value added (constant 2005 US$) in Romania in 2012 and the Value added (constant 2005 US$) in Tanzania in 2013?
Your answer should be very brief. 5.65e+1. What is the difference between the Value added (constant 2005 US$) of Dominican Republic in 2012 and the Value added (constant 2005 US$) of Nicaragua in 2014?
Your response must be concise. 2.49e+1. What is the difference between the Value added (constant 2005 US$) of Dominican Republic in 2012 and the Value added (constant 2005 US$) of Romania in 2014?
Your answer should be very brief. -4.39e+1. What is the difference between the Value added (constant 2005 US$) of Dominican Republic in 2012 and the Value added (constant 2005 US$) of Tanzania in 2014?
Make the answer very short. 1.60e+1. What is the difference between the Value added (constant 2005 US$) in Nicaragua in 2012 and the Value added (constant 2005 US$) in Romania in 2014?
Your answer should be very brief. -6.93e+1. What is the difference between the Value added (constant 2005 US$) in Nicaragua in 2012 and the Value added (constant 2005 US$) in Tanzania in 2014?
Provide a short and direct response. -9.39e+09. What is the difference between the Value added (constant 2005 US$) in Romania in 2012 and the Value added (constant 2005 US$) in Tanzania in 2014?
Offer a terse response. 5.56e+1. What is the difference between the Value added (constant 2005 US$) in Dominican Republic in 2013 and the Value added (constant 2005 US$) in Nicaragua in 2014?
Ensure brevity in your answer.  2.59e+1. What is the difference between the Value added (constant 2005 US$) in Dominican Republic in 2013 and the Value added (constant 2005 US$) in Romania in 2014?
Your answer should be compact. -4.29e+1. What is the difference between the Value added (constant 2005 US$) of Dominican Republic in 2013 and the Value added (constant 2005 US$) of Tanzania in 2014?
Give a very brief answer. 1.70e+1. What is the difference between the Value added (constant 2005 US$) of Nicaragua in 2013 and the Value added (constant 2005 US$) of Romania in 2014?
Give a very brief answer. -6.90e+1. What is the difference between the Value added (constant 2005 US$) in Nicaragua in 2013 and the Value added (constant 2005 US$) in Tanzania in 2014?
Ensure brevity in your answer.  -9.16e+09. What is the difference between the Value added (constant 2005 US$) in Romania in 2013 and the Value added (constant 2005 US$) in Tanzania in 2014?
Give a very brief answer. 5.65e+1. What is the average Value added (constant 2005 US$) of Dominican Republic per year?
Your answer should be very brief. 2.81e+1. What is the average Value added (constant 2005 US$) in Nicaragua per year?
Provide a short and direct response. 4.30e+09. What is the average Value added (constant 2005 US$) in Romania per year?
Provide a succinct answer. 6.95e+1. What is the average Value added (constant 2005 US$) of Tanzania per year?
Provide a succinct answer. 1.11e+1. In the year 2007, what is the difference between the Value added (constant 2005 US$) in Dominican Republic and Value added (constant 2005 US$) in Nicaragua?
Offer a terse response. 2.02e+1. In the year 2007, what is the difference between the Value added (constant 2005 US$) in Dominican Republic and Value added (constant 2005 US$) in Romania?
Keep it short and to the point. -4.51e+1. In the year 2007, what is the difference between the Value added (constant 2005 US$) in Dominican Republic and Value added (constant 2005 US$) in Tanzania?
Provide a short and direct response. 1.51e+1. In the year 2007, what is the difference between the Value added (constant 2005 US$) of Nicaragua and Value added (constant 2005 US$) of Romania?
Make the answer very short. -6.53e+1. In the year 2007, what is the difference between the Value added (constant 2005 US$) of Nicaragua and Value added (constant 2005 US$) of Tanzania?
Provide a short and direct response. -5.07e+09. In the year 2007, what is the difference between the Value added (constant 2005 US$) in Romania and Value added (constant 2005 US$) in Tanzania?
Your answer should be compact. 6.02e+1. In the year 2008, what is the difference between the Value added (constant 2005 US$) in Dominican Republic and Value added (constant 2005 US$) in Nicaragua?
Provide a succinct answer. 2.12e+1. In the year 2008, what is the difference between the Value added (constant 2005 US$) in Dominican Republic and Value added (constant 2005 US$) in Romania?
Offer a terse response. -4.94e+1. In the year 2008, what is the difference between the Value added (constant 2005 US$) in Dominican Republic and Value added (constant 2005 US$) in Tanzania?
Your answer should be very brief. 1.59e+1. In the year 2008, what is the difference between the Value added (constant 2005 US$) of Nicaragua and Value added (constant 2005 US$) of Romania?
Your answer should be compact. -7.06e+1. In the year 2008, what is the difference between the Value added (constant 2005 US$) in Nicaragua and Value added (constant 2005 US$) in Tanzania?
Provide a short and direct response. -5.22e+09. In the year 2008, what is the difference between the Value added (constant 2005 US$) of Romania and Value added (constant 2005 US$) of Tanzania?
Your response must be concise. 6.54e+1. In the year 2009, what is the difference between the Value added (constant 2005 US$) of Dominican Republic and Value added (constant 2005 US$) of Nicaragua?
Provide a succinct answer. 2.18e+1. In the year 2009, what is the difference between the Value added (constant 2005 US$) in Dominican Republic and Value added (constant 2005 US$) in Romania?
Offer a very short reply. -4.29e+1. In the year 2009, what is the difference between the Value added (constant 2005 US$) of Dominican Republic and Value added (constant 2005 US$) of Tanzania?
Your response must be concise. 1.60e+1. In the year 2009, what is the difference between the Value added (constant 2005 US$) in Nicaragua and Value added (constant 2005 US$) in Romania?
Offer a very short reply. -6.47e+1. In the year 2009, what is the difference between the Value added (constant 2005 US$) in Nicaragua and Value added (constant 2005 US$) in Tanzania?
Give a very brief answer. -5.76e+09. In the year 2009, what is the difference between the Value added (constant 2005 US$) in Romania and Value added (constant 2005 US$) in Tanzania?
Ensure brevity in your answer.  5.89e+1. In the year 2010, what is the difference between the Value added (constant 2005 US$) of Dominican Republic and Value added (constant 2005 US$) of Nicaragua?
Ensure brevity in your answer.  2.37e+1. In the year 2010, what is the difference between the Value added (constant 2005 US$) in Dominican Republic and Value added (constant 2005 US$) in Romania?
Make the answer very short. -3.75e+1. In the year 2010, what is the difference between the Value added (constant 2005 US$) of Dominican Republic and Value added (constant 2005 US$) of Tanzania?
Ensure brevity in your answer.  1.73e+1. In the year 2010, what is the difference between the Value added (constant 2005 US$) in Nicaragua and Value added (constant 2005 US$) in Romania?
Provide a succinct answer. -6.12e+1. In the year 2010, what is the difference between the Value added (constant 2005 US$) in Nicaragua and Value added (constant 2005 US$) in Tanzania?
Make the answer very short. -6.32e+09. In the year 2010, what is the difference between the Value added (constant 2005 US$) of Romania and Value added (constant 2005 US$) of Tanzania?
Offer a very short reply. 5.49e+1. In the year 2011, what is the difference between the Value added (constant 2005 US$) of Dominican Republic and Value added (constant 2005 US$) of Nicaragua?
Your response must be concise. 2.44e+1. In the year 2011, what is the difference between the Value added (constant 2005 US$) of Dominican Republic and Value added (constant 2005 US$) of Romania?
Give a very brief answer. -3.59e+1. In the year 2011, what is the difference between the Value added (constant 2005 US$) of Dominican Republic and Value added (constant 2005 US$) of Tanzania?
Offer a very short reply. 1.74e+1. In the year 2011, what is the difference between the Value added (constant 2005 US$) of Nicaragua and Value added (constant 2005 US$) of Romania?
Provide a succinct answer. -6.03e+1. In the year 2011, what is the difference between the Value added (constant 2005 US$) in Nicaragua and Value added (constant 2005 US$) in Tanzania?
Keep it short and to the point. -6.97e+09. In the year 2011, what is the difference between the Value added (constant 2005 US$) of Romania and Value added (constant 2005 US$) of Tanzania?
Offer a terse response. 5.33e+1. In the year 2012, what is the difference between the Value added (constant 2005 US$) of Dominican Republic and Value added (constant 2005 US$) of Nicaragua?
Offer a terse response. 2.54e+1. In the year 2012, what is the difference between the Value added (constant 2005 US$) in Dominican Republic and Value added (constant 2005 US$) in Romania?
Ensure brevity in your answer.  -3.96e+1. In the year 2012, what is the difference between the Value added (constant 2005 US$) of Dominican Republic and Value added (constant 2005 US$) of Tanzania?
Make the answer very short. 1.78e+1. In the year 2012, what is the difference between the Value added (constant 2005 US$) in Nicaragua and Value added (constant 2005 US$) in Romania?
Make the answer very short. -6.50e+1. In the year 2012, what is the difference between the Value added (constant 2005 US$) in Nicaragua and Value added (constant 2005 US$) in Tanzania?
Make the answer very short. -7.57e+09. In the year 2012, what is the difference between the Value added (constant 2005 US$) of Romania and Value added (constant 2005 US$) of Tanzania?
Make the answer very short. 5.74e+1. In the year 2013, what is the difference between the Value added (constant 2005 US$) in Dominican Republic and Value added (constant 2005 US$) in Nicaragua?
Offer a terse response. 2.61e+1. In the year 2013, what is the difference between the Value added (constant 2005 US$) in Dominican Republic and Value added (constant 2005 US$) in Romania?
Keep it short and to the point. -3.95e+1. In the year 2013, what is the difference between the Value added (constant 2005 US$) of Dominican Republic and Value added (constant 2005 US$) of Tanzania?
Provide a succinct answer. 1.79e+1. In the year 2013, what is the difference between the Value added (constant 2005 US$) of Nicaragua and Value added (constant 2005 US$) of Romania?
Offer a very short reply. -6.57e+1. In the year 2013, what is the difference between the Value added (constant 2005 US$) of Nicaragua and Value added (constant 2005 US$) of Tanzania?
Provide a short and direct response. -8.23e+09. In the year 2013, what is the difference between the Value added (constant 2005 US$) in Romania and Value added (constant 2005 US$) in Tanzania?
Ensure brevity in your answer.  5.74e+1. In the year 2014, what is the difference between the Value added (constant 2005 US$) of Dominican Republic and Value added (constant 2005 US$) of Nicaragua?
Provide a short and direct response. 2.76e+1. In the year 2014, what is the difference between the Value added (constant 2005 US$) in Dominican Republic and Value added (constant 2005 US$) in Romania?
Your answer should be very brief. -4.12e+1. In the year 2014, what is the difference between the Value added (constant 2005 US$) in Dominican Republic and Value added (constant 2005 US$) in Tanzania?
Your response must be concise. 1.87e+1. In the year 2014, what is the difference between the Value added (constant 2005 US$) of Nicaragua and Value added (constant 2005 US$) of Romania?
Offer a very short reply. -6.88e+1. In the year 2014, what is the difference between the Value added (constant 2005 US$) in Nicaragua and Value added (constant 2005 US$) in Tanzania?
Make the answer very short. -8.90e+09. In the year 2014, what is the difference between the Value added (constant 2005 US$) in Romania and Value added (constant 2005 US$) in Tanzania?
Your response must be concise. 5.99e+1. What is the ratio of the Value added (constant 2005 US$) of Dominican Republic in 2007 to that in 2008?
Provide a short and direct response. 0.95. What is the ratio of the Value added (constant 2005 US$) of Nicaragua in 2007 to that in 2008?
Give a very brief answer. 0.95. What is the ratio of the Value added (constant 2005 US$) in Romania in 2007 to that in 2008?
Give a very brief answer. 0.93. What is the ratio of the Value added (constant 2005 US$) of Tanzania in 2007 to that in 2008?
Give a very brief answer. 0.96. What is the ratio of the Value added (constant 2005 US$) in Dominican Republic in 2007 to that in 2009?
Your answer should be very brief. 0.93. What is the ratio of the Value added (constant 2005 US$) of Nicaragua in 2007 to that in 2009?
Offer a terse response. 0.96. What is the ratio of the Value added (constant 2005 US$) in Romania in 2007 to that in 2009?
Ensure brevity in your answer.  1.01. What is the ratio of the Value added (constant 2005 US$) in Tanzania in 2007 to that in 2009?
Provide a succinct answer. 0.91. What is the ratio of the Value added (constant 2005 US$) of Dominican Republic in 2007 to that in 2010?
Your answer should be very brief. 0.86. What is the ratio of the Value added (constant 2005 US$) of Nicaragua in 2007 to that in 2010?
Ensure brevity in your answer.  0.91. What is the ratio of the Value added (constant 2005 US$) of Romania in 2007 to that in 2010?
Give a very brief answer. 1.06. What is the ratio of the Value added (constant 2005 US$) in Tanzania in 2007 to that in 2010?
Keep it short and to the point. 0.85. What is the ratio of the Value added (constant 2005 US$) of Dominican Republic in 2007 to that in 2011?
Offer a terse response. 0.83. What is the ratio of the Value added (constant 2005 US$) in Nicaragua in 2007 to that in 2011?
Provide a short and direct response. 0.87. What is the ratio of the Value added (constant 2005 US$) of Romania in 2007 to that in 2011?
Provide a short and direct response. 1.07. What is the ratio of the Value added (constant 2005 US$) in Tanzania in 2007 to that in 2011?
Your answer should be very brief. 0.78. What is the ratio of the Value added (constant 2005 US$) of Dominican Republic in 2007 to that in 2012?
Keep it short and to the point. 0.8. What is the ratio of the Value added (constant 2005 US$) in Nicaragua in 2007 to that in 2012?
Offer a terse response. 0.83. What is the ratio of the Value added (constant 2005 US$) in Romania in 2007 to that in 2012?
Provide a short and direct response. 0.99. What is the ratio of the Value added (constant 2005 US$) of Tanzania in 2007 to that in 2012?
Offer a very short reply. 0.73. What is the ratio of the Value added (constant 2005 US$) of Dominican Republic in 2007 to that in 2013?
Provide a succinct answer. 0.77. What is the ratio of the Value added (constant 2005 US$) of Nicaragua in 2007 to that in 2013?
Offer a very short reply. 0.79. What is the ratio of the Value added (constant 2005 US$) in Romania in 2007 to that in 2013?
Give a very brief answer. 0.98. What is the ratio of the Value added (constant 2005 US$) of Tanzania in 2007 to that in 2013?
Ensure brevity in your answer.  0.68. What is the ratio of the Value added (constant 2005 US$) of Dominican Republic in 2007 to that in 2014?
Your response must be concise. 0.73. What is the ratio of the Value added (constant 2005 US$) in Nicaragua in 2007 to that in 2014?
Provide a short and direct response. 0.75. What is the ratio of the Value added (constant 2005 US$) in Romania in 2007 to that in 2014?
Provide a short and direct response. 0.94. What is the ratio of the Value added (constant 2005 US$) in Tanzania in 2007 to that in 2014?
Keep it short and to the point. 0.63. What is the ratio of the Value added (constant 2005 US$) of Nicaragua in 2008 to that in 2009?
Offer a very short reply. 1.01. What is the ratio of the Value added (constant 2005 US$) of Romania in 2008 to that in 2009?
Ensure brevity in your answer.  1.09. What is the ratio of the Value added (constant 2005 US$) of Tanzania in 2008 to that in 2009?
Offer a terse response. 0.95. What is the ratio of the Value added (constant 2005 US$) in Dominican Republic in 2008 to that in 2010?
Ensure brevity in your answer.  0.9. What is the ratio of the Value added (constant 2005 US$) of Nicaragua in 2008 to that in 2010?
Your answer should be compact. 0.96. What is the ratio of the Value added (constant 2005 US$) in Romania in 2008 to that in 2010?
Offer a terse response. 1.14. What is the ratio of the Value added (constant 2005 US$) of Tanzania in 2008 to that in 2010?
Provide a short and direct response. 0.88. What is the ratio of the Value added (constant 2005 US$) in Dominican Republic in 2008 to that in 2011?
Offer a terse response. 0.88. What is the ratio of the Value added (constant 2005 US$) in Nicaragua in 2008 to that in 2011?
Your answer should be compact. 0.92. What is the ratio of the Value added (constant 2005 US$) of Romania in 2008 to that in 2011?
Provide a short and direct response. 1.15. What is the ratio of the Value added (constant 2005 US$) in Tanzania in 2008 to that in 2011?
Keep it short and to the point. 0.82. What is the ratio of the Value added (constant 2005 US$) of Dominican Republic in 2008 to that in 2012?
Keep it short and to the point. 0.84. What is the ratio of the Value added (constant 2005 US$) in Nicaragua in 2008 to that in 2012?
Ensure brevity in your answer.  0.88. What is the ratio of the Value added (constant 2005 US$) in Romania in 2008 to that in 2012?
Make the answer very short. 1.07. What is the ratio of the Value added (constant 2005 US$) in Tanzania in 2008 to that in 2012?
Make the answer very short. 0.76. What is the ratio of the Value added (constant 2005 US$) of Dominican Republic in 2008 to that in 2013?
Your answer should be compact. 0.81. What is the ratio of the Value added (constant 2005 US$) in Nicaragua in 2008 to that in 2013?
Offer a terse response. 0.83. What is the ratio of the Value added (constant 2005 US$) in Romania in 2008 to that in 2013?
Provide a short and direct response. 1.06. What is the ratio of the Value added (constant 2005 US$) in Tanzania in 2008 to that in 2013?
Provide a short and direct response. 0.71. What is the ratio of the Value added (constant 2005 US$) of Dominican Republic in 2008 to that in 2014?
Ensure brevity in your answer.  0.77. What is the ratio of the Value added (constant 2005 US$) in Nicaragua in 2008 to that in 2014?
Offer a very short reply. 0.79. What is the ratio of the Value added (constant 2005 US$) in Romania in 2008 to that in 2014?
Provide a short and direct response. 1.01. What is the ratio of the Value added (constant 2005 US$) in Tanzania in 2008 to that in 2014?
Offer a very short reply. 0.66. What is the ratio of the Value added (constant 2005 US$) in Dominican Republic in 2009 to that in 2010?
Offer a very short reply. 0.92. What is the ratio of the Value added (constant 2005 US$) in Nicaragua in 2009 to that in 2010?
Ensure brevity in your answer.  0.95. What is the ratio of the Value added (constant 2005 US$) in Romania in 2009 to that in 2010?
Make the answer very short. 1.05. What is the ratio of the Value added (constant 2005 US$) of Tanzania in 2009 to that in 2010?
Your response must be concise. 0.93. What is the ratio of the Value added (constant 2005 US$) of Dominican Republic in 2009 to that in 2011?
Make the answer very short. 0.9. What is the ratio of the Value added (constant 2005 US$) of Nicaragua in 2009 to that in 2011?
Provide a short and direct response. 0.91. What is the ratio of the Value added (constant 2005 US$) of Romania in 2009 to that in 2011?
Offer a very short reply. 1.06. What is the ratio of the Value added (constant 2005 US$) in Tanzania in 2009 to that in 2011?
Provide a short and direct response. 0.86. What is the ratio of the Value added (constant 2005 US$) in Dominican Republic in 2009 to that in 2012?
Offer a very short reply. 0.86. What is the ratio of the Value added (constant 2005 US$) in Nicaragua in 2009 to that in 2012?
Keep it short and to the point. 0.87. What is the ratio of the Value added (constant 2005 US$) of Romania in 2009 to that in 2012?
Your answer should be compact. 0.99. What is the ratio of the Value added (constant 2005 US$) in Tanzania in 2009 to that in 2012?
Your answer should be compact. 0.8. What is the ratio of the Value added (constant 2005 US$) of Dominican Republic in 2009 to that in 2013?
Provide a short and direct response. 0.83. What is the ratio of the Value added (constant 2005 US$) in Nicaragua in 2009 to that in 2013?
Provide a succinct answer. 0.82. What is the ratio of the Value added (constant 2005 US$) of Romania in 2009 to that in 2013?
Keep it short and to the point. 0.97. What is the ratio of the Value added (constant 2005 US$) in Tanzania in 2009 to that in 2013?
Make the answer very short. 0.75. What is the ratio of the Value added (constant 2005 US$) of Dominican Republic in 2009 to that in 2014?
Give a very brief answer. 0.79. What is the ratio of the Value added (constant 2005 US$) of Nicaragua in 2009 to that in 2014?
Your answer should be very brief. 0.78. What is the ratio of the Value added (constant 2005 US$) in Romania in 2009 to that in 2014?
Your answer should be very brief. 0.93. What is the ratio of the Value added (constant 2005 US$) in Tanzania in 2009 to that in 2014?
Ensure brevity in your answer.  0.7. What is the ratio of the Value added (constant 2005 US$) of Dominican Republic in 2010 to that in 2011?
Your response must be concise. 0.97. What is the ratio of the Value added (constant 2005 US$) in Nicaragua in 2010 to that in 2011?
Your response must be concise. 0.96. What is the ratio of the Value added (constant 2005 US$) of Romania in 2010 to that in 2011?
Keep it short and to the point. 1.01. What is the ratio of the Value added (constant 2005 US$) in Tanzania in 2010 to that in 2011?
Your answer should be very brief. 0.93. What is the ratio of the Value added (constant 2005 US$) of Dominican Republic in 2010 to that in 2012?
Provide a succinct answer. 0.93. What is the ratio of the Value added (constant 2005 US$) of Nicaragua in 2010 to that in 2012?
Make the answer very short. 0.91. What is the ratio of the Value added (constant 2005 US$) in Romania in 2010 to that in 2012?
Keep it short and to the point. 0.94. What is the ratio of the Value added (constant 2005 US$) of Tanzania in 2010 to that in 2012?
Offer a terse response. 0.86. What is the ratio of the Value added (constant 2005 US$) in Dominican Republic in 2010 to that in 2013?
Keep it short and to the point. 0.9. What is the ratio of the Value added (constant 2005 US$) of Nicaragua in 2010 to that in 2013?
Your answer should be very brief. 0.87. What is the ratio of the Value added (constant 2005 US$) in Romania in 2010 to that in 2013?
Provide a short and direct response. 0.93. What is the ratio of the Value added (constant 2005 US$) in Tanzania in 2010 to that in 2013?
Your response must be concise. 0.8. What is the ratio of the Value added (constant 2005 US$) of Dominican Republic in 2010 to that in 2014?
Provide a short and direct response. 0.85. What is the ratio of the Value added (constant 2005 US$) in Nicaragua in 2010 to that in 2014?
Offer a very short reply. 0.82. What is the ratio of the Value added (constant 2005 US$) of Romania in 2010 to that in 2014?
Your answer should be compact. 0.89. What is the ratio of the Value added (constant 2005 US$) of Tanzania in 2010 to that in 2014?
Provide a short and direct response. 0.75. What is the ratio of the Value added (constant 2005 US$) in Dominican Republic in 2011 to that in 2012?
Keep it short and to the point. 0.96. What is the ratio of the Value added (constant 2005 US$) of Nicaragua in 2011 to that in 2012?
Your answer should be compact. 0.95. What is the ratio of the Value added (constant 2005 US$) in Romania in 2011 to that in 2012?
Your answer should be very brief. 0.93. What is the ratio of the Value added (constant 2005 US$) of Tanzania in 2011 to that in 2012?
Keep it short and to the point. 0.93. What is the ratio of the Value added (constant 2005 US$) of Dominican Republic in 2011 to that in 2013?
Your response must be concise. 0.93. What is the ratio of the Value added (constant 2005 US$) in Nicaragua in 2011 to that in 2013?
Your response must be concise. 0.9. What is the ratio of the Value added (constant 2005 US$) in Romania in 2011 to that in 2013?
Provide a succinct answer. 0.92. What is the ratio of the Value added (constant 2005 US$) of Tanzania in 2011 to that in 2013?
Offer a very short reply. 0.87. What is the ratio of the Value added (constant 2005 US$) in Dominican Republic in 2011 to that in 2014?
Offer a terse response. 0.88. What is the ratio of the Value added (constant 2005 US$) of Nicaragua in 2011 to that in 2014?
Your answer should be compact. 0.85. What is the ratio of the Value added (constant 2005 US$) of Romania in 2011 to that in 2014?
Offer a very short reply. 0.88. What is the ratio of the Value added (constant 2005 US$) in Tanzania in 2011 to that in 2014?
Give a very brief answer. 0.81. What is the ratio of the Value added (constant 2005 US$) in Dominican Republic in 2012 to that in 2013?
Your answer should be compact. 0.97. What is the ratio of the Value added (constant 2005 US$) in Nicaragua in 2012 to that in 2013?
Your answer should be compact. 0.95. What is the ratio of the Value added (constant 2005 US$) of Tanzania in 2012 to that in 2013?
Make the answer very short. 0.93. What is the ratio of the Value added (constant 2005 US$) of Dominican Republic in 2012 to that in 2014?
Make the answer very short. 0.92. What is the ratio of the Value added (constant 2005 US$) of Nicaragua in 2012 to that in 2014?
Offer a terse response. 0.9. What is the ratio of the Value added (constant 2005 US$) in Romania in 2012 to that in 2014?
Your answer should be very brief. 0.94. What is the ratio of the Value added (constant 2005 US$) of Tanzania in 2012 to that in 2014?
Your answer should be very brief. 0.87. What is the ratio of the Value added (constant 2005 US$) of Dominican Republic in 2013 to that in 2014?
Keep it short and to the point. 0.95. What is the ratio of the Value added (constant 2005 US$) of Nicaragua in 2013 to that in 2014?
Provide a short and direct response. 0.95. What is the ratio of the Value added (constant 2005 US$) in Romania in 2013 to that in 2014?
Provide a short and direct response. 0.95. What is the ratio of the Value added (constant 2005 US$) in Tanzania in 2013 to that in 2014?
Your answer should be compact. 0.93. What is the difference between the highest and the second highest Value added (constant 2005 US$) of Dominican Republic?
Offer a terse response. 1.75e+09. What is the difference between the highest and the second highest Value added (constant 2005 US$) in Nicaragua?
Give a very brief answer. 2.62e+08. What is the difference between the highest and the second highest Value added (constant 2005 US$) of Romania?
Offer a very short reply. 7.50e+08. What is the difference between the highest and the second highest Value added (constant 2005 US$) in Tanzania?
Keep it short and to the point. 9.26e+08. What is the difference between the highest and the lowest Value added (constant 2005 US$) of Dominican Republic?
Provide a succinct answer. 8.73e+09. What is the difference between the highest and the lowest Value added (constant 2005 US$) in Nicaragua?
Your response must be concise. 1.27e+09. What is the difference between the highest and the lowest Value added (constant 2005 US$) of Romania?
Your answer should be very brief. 9.97e+09. What is the difference between the highest and the lowest Value added (constant 2005 US$) in Tanzania?
Offer a very short reply. 5.10e+09. 